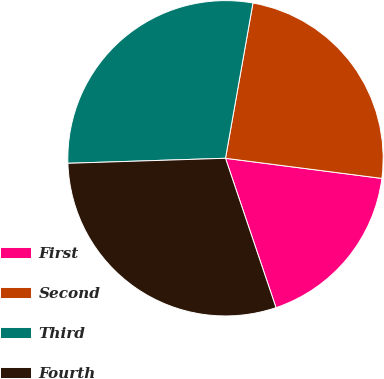Convert chart. <chart><loc_0><loc_0><loc_500><loc_500><pie_chart><fcel>First<fcel>Second<fcel>Third<fcel>Fourth<nl><fcel>17.77%<fcel>24.25%<fcel>28.29%<fcel>29.68%<nl></chart> 